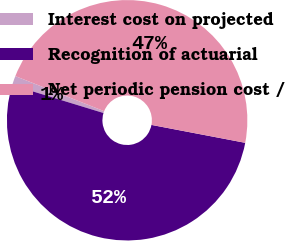Convert chart to OTSL. <chart><loc_0><loc_0><loc_500><loc_500><pie_chart><fcel>Interest cost on projected<fcel>Recognition of actuarial<fcel>Net periodic pension cost /<nl><fcel>1.26%<fcel>51.72%<fcel>47.02%<nl></chart> 